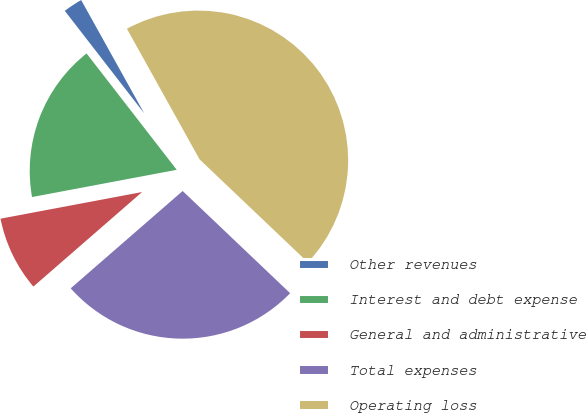<chart> <loc_0><loc_0><loc_500><loc_500><pie_chart><fcel>Other revenues<fcel>Interest and debt expense<fcel>General and administrative<fcel>Total expenses<fcel>Operating loss<nl><fcel>2.41%<fcel>17.47%<fcel>8.43%<fcel>26.51%<fcel>45.18%<nl></chart> 